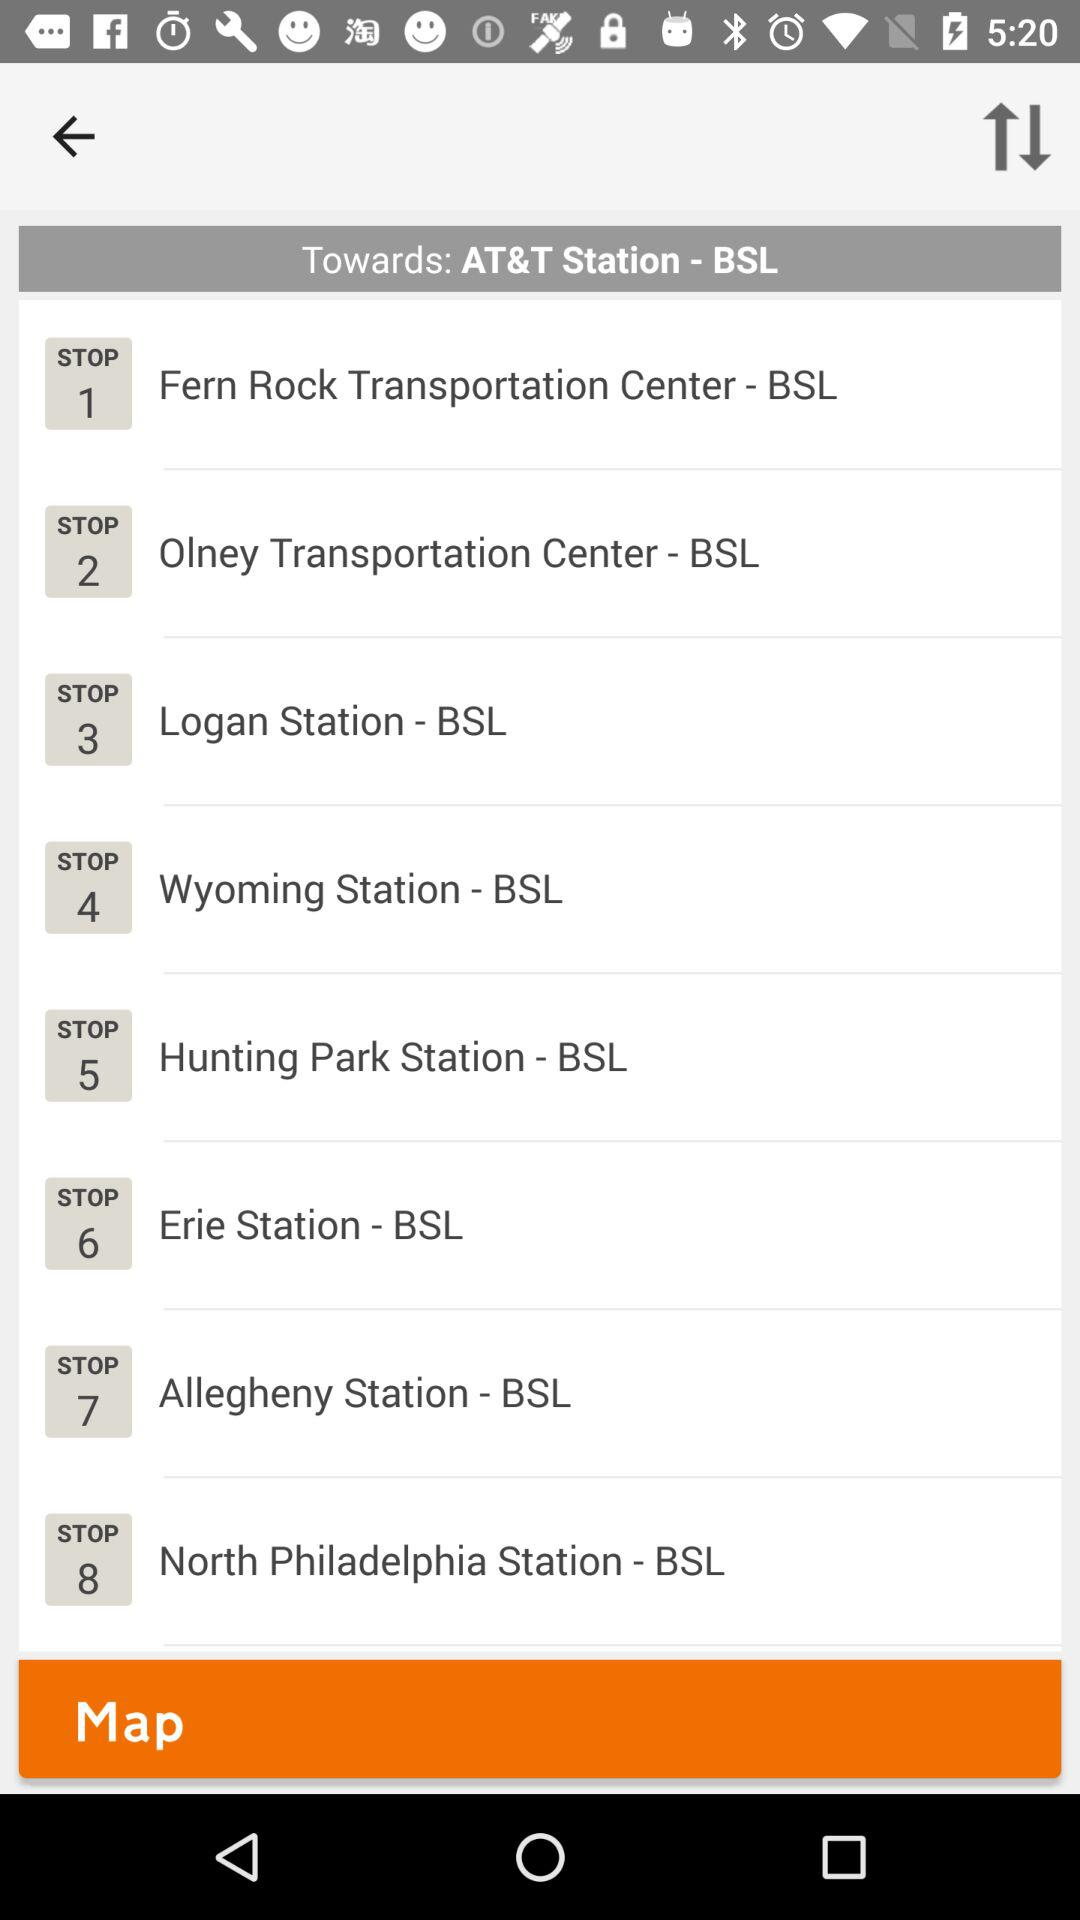What's the "Erie Station - BSL" stop number? The 'Erie Station - BSL' is designated as stop number 6 on the route towards AT&T Station on the BSL (Broad Street Line) in Philadelphia. 